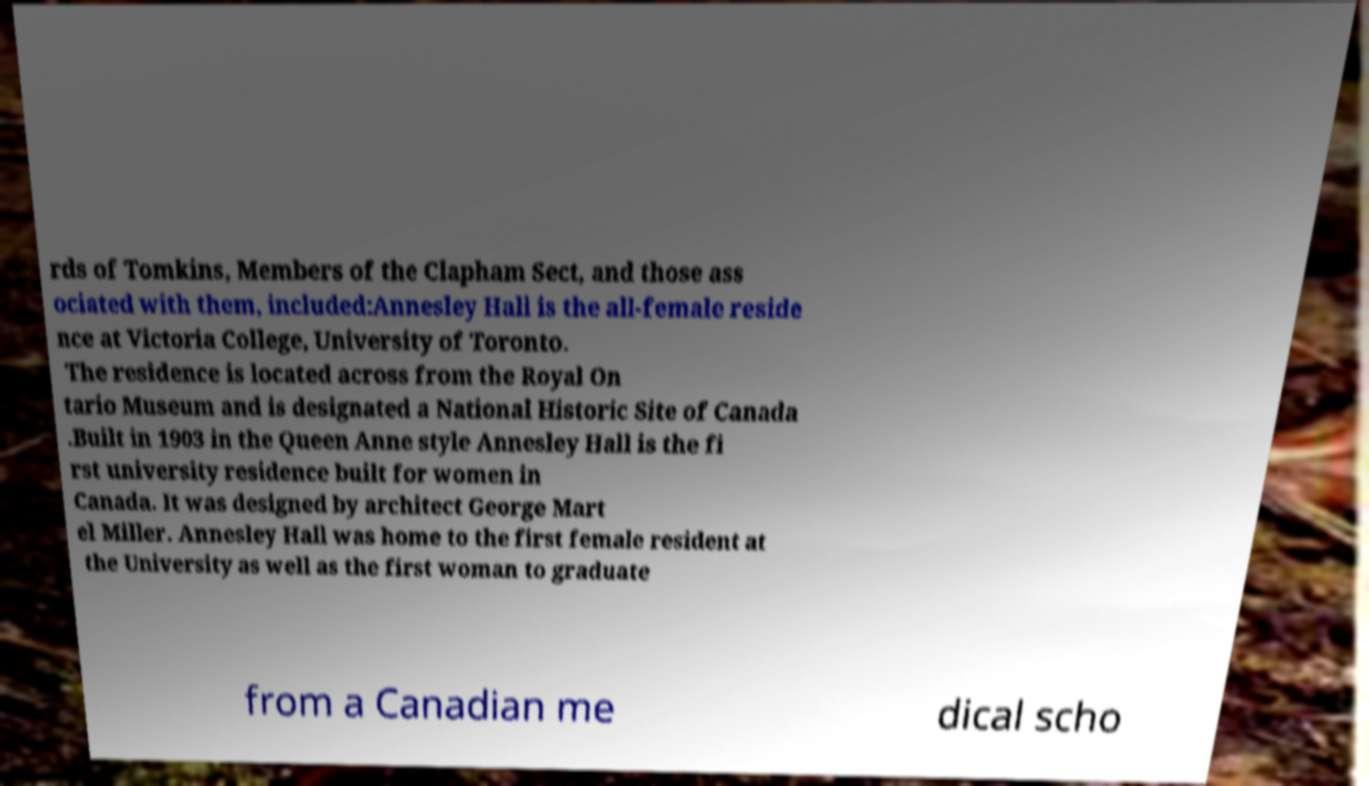I need the written content from this picture converted into text. Can you do that? rds of Tomkins, Members of the Clapham Sect, and those ass ociated with them, included:Annesley Hall is the all-female reside nce at Victoria College, University of Toronto. The residence is located across from the Royal On tario Museum and is designated a National Historic Site of Canada .Built in 1903 in the Queen Anne style Annesley Hall is the fi rst university residence built for women in Canada. It was designed by architect George Mart el Miller. Annesley Hall was home to the first female resident at the University as well as the first woman to graduate from a Canadian me dical scho 